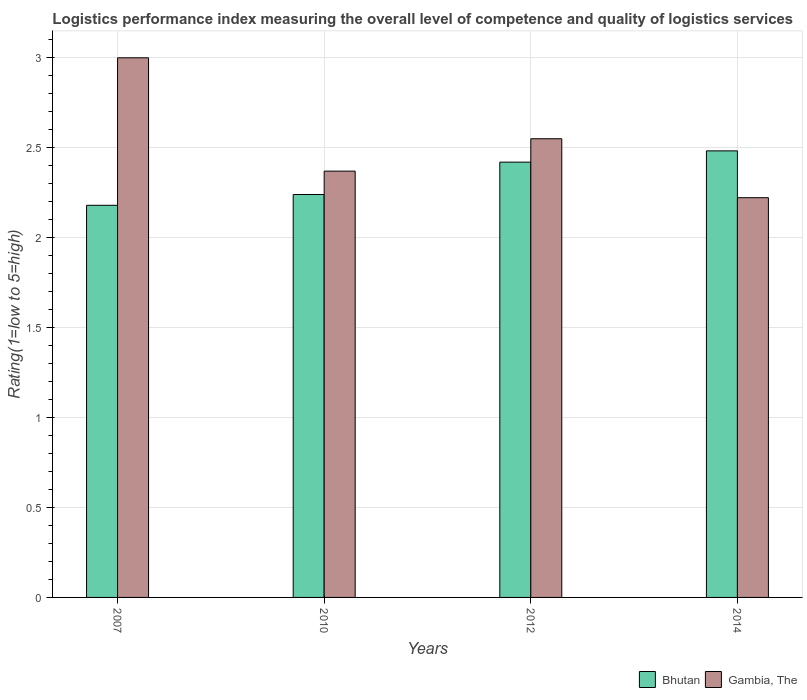How many different coloured bars are there?
Offer a very short reply. 2. How many groups of bars are there?
Make the answer very short. 4. Are the number of bars per tick equal to the number of legend labels?
Your answer should be very brief. Yes. Are the number of bars on each tick of the X-axis equal?
Provide a short and direct response. Yes. In how many cases, is the number of bars for a given year not equal to the number of legend labels?
Offer a very short reply. 0. What is the Logistic performance index in Bhutan in 2007?
Your response must be concise. 2.18. Across all years, what is the maximum Logistic performance index in Bhutan?
Offer a very short reply. 2.48. Across all years, what is the minimum Logistic performance index in Gambia, The?
Provide a short and direct response. 2.22. What is the total Logistic performance index in Bhutan in the graph?
Your answer should be compact. 9.32. What is the difference between the Logistic performance index in Bhutan in 2012 and that in 2014?
Make the answer very short. -0.06. What is the difference between the Logistic performance index in Gambia, The in 2007 and the Logistic performance index in Bhutan in 2014?
Give a very brief answer. 0.52. What is the average Logistic performance index in Gambia, The per year?
Ensure brevity in your answer.  2.54. In the year 2012, what is the difference between the Logistic performance index in Bhutan and Logistic performance index in Gambia, The?
Ensure brevity in your answer.  -0.13. What is the ratio of the Logistic performance index in Bhutan in 2010 to that in 2014?
Keep it short and to the point. 0.9. What is the difference between the highest and the second highest Logistic performance index in Bhutan?
Your answer should be very brief. 0.06. What is the difference between the highest and the lowest Logistic performance index in Gambia, The?
Offer a very short reply. 0.78. Is the sum of the Logistic performance index in Bhutan in 2010 and 2014 greater than the maximum Logistic performance index in Gambia, The across all years?
Ensure brevity in your answer.  Yes. What does the 2nd bar from the left in 2012 represents?
Keep it short and to the point. Gambia, The. What does the 2nd bar from the right in 2012 represents?
Make the answer very short. Bhutan. How many bars are there?
Your response must be concise. 8. Are all the bars in the graph horizontal?
Keep it short and to the point. No. What is the difference between two consecutive major ticks on the Y-axis?
Provide a succinct answer. 0.5. Does the graph contain grids?
Offer a terse response. Yes. How many legend labels are there?
Your answer should be very brief. 2. How are the legend labels stacked?
Your response must be concise. Horizontal. What is the title of the graph?
Your response must be concise. Logistics performance index measuring the overall level of competence and quality of logistics services. Does "Nepal" appear as one of the legend labels in the graph?
Keep it short and to the point. No. What is the label or title of the Y-axis?
Your answer should be compact. Rating(1=low to 5=high). What is the Rating(1=low to 5=high) in Bhutan in 2007?
Provide a succinct answer. 2.18. What is the Rating(1=low to 5=high) in Bhutan in 2010?
Keep it short and to the point. 2.24. What is the Rating(1=low to 5=high) in Gambia, The in 2010?
Ensure brevity in your answer.  2.37. What is the Rating(1=low to 5=high) in Bhutan in 2012?
Ensure brevity in your answer.  2.42. What is the Rating(1=low to 5=high) in Gambia, The in 2012?
Give a very brief answer. 2.55. What is the Rating(1=low to 5=high) in Bhutan in 2014?
Offer a terse response. 2.48. What is the Rating(1=low to 5=high) of Gambia, The in 2014?
Keep it short and to the point. 2.22. Across all years, what is the maximum Rating(1=low to 5=high) of Bhutan?
Your answer should be compact. 2.48. Across all years, what is the maximum Rating(1=low to 5=high) in Gambia, The?
Provide a succinct answer. 3. Across all years, what is the minimum Rating(1=low to 5=high) in Bhutan?
Offer a very short reply. 2.18. Across all years, what is the minimum Rating(1=low to 5=high) in Gambia, The?
Your response must be concise. 2.22. What is the total Rating(1=low to 5=high) of Bhutan in the graph?
Keep it short and to the point. 9.32. What is the total Rating(1=low to 5=high) of Gambia, The in the graph?
Offer a very short reply. 10.14. What is the difference between the Rating(1=low to 5=high) in Bhutan in 2007 and that in 2010?
Give a very brief answer. -0.06. What is the difference between the Rating(1=low to 5=high) in Gambia, The in 2007 and that in 2010?
Ensure brevity in your answer.  0.63. What is the difference between the Rating(1=low to 5=high) in Bhutan in 2007 and that in 2012?
Your answer should be very brief. -0.24. What is the difference between the Rating(1=low to 5=high) of Gambia, The in 2007 and that in 2012?
Your response must be concise. 0.45. What is the difference between the Rating(1=low to 5=high) in Bhutan in 2007 and that in 2014?
Your response must be concise. -0.3. What is the difference between the Rating(1=low to 5=high) in Bhutan in 2010 and that in 2012?
Provide a short and direct response. -0.18. What is the difference between the Rating(1=low to 5=high) in Gambia, The in 2010 and that in 2012?
Give a very brief answer. -0.18. What is the difference between the Rating(1=low to 5=high) in Bhutan in 2010 and that in 2014?
Ensure brevity in your answer.  -0.24. What is the difference between the Rating(1=low to 5=high) in Gambia, The in 2010 and that in 2014?
Provide a short and direct response. 0.15. What is the difference between the Rating(1=low to 5=high) of Bhutan in 2012 and that in 2014?
Keep it short and to the point. -0.06. What is the difference between the Rating(1=low to 5=high) of Gambia, The in 2012 and that in 2014?
Provide a succinct answer. 0.33. What is the difference between the Rating(1=low to 5=high) of Bhutan in 2007 and the Rating(1=low to 5=high) of Gambia, The in 2010?
Your answer should be very brief. -0.19. What is the difference between the Rating(1=low to 5=high) in Bhutan in 2007 and the Rating(1=low to 5=high) in Gambia, The in 2012?
Your response must be concise. -0.37. What is the difference between the Rating(1=low to 5=high) in Bhutan in 2007 and the Rating(1=low to 5=high) in Gambia, The in 2014?
Give a very brief answer. -0.04. What is the difference between the Rating(1=low to 5=high) of Bhutan in 2010 and the Rating(1=low to 5=high) of Gambia, The in 2012?
Make the answer very short. -0.31. What is the difference between the Rating(1=low to 5=high) of Bhutan in 2010 and the Rating(1=low to 5=high) of Gambia, The in 2014?
Your answer should be compact. 0.02. What is the difference between the Rating(1=low to 5=high) of Bhutan in 2012 and the Rating(1=low to 5=high) of Gambia, The in 2014?
Make the answer very short. 0.2. What is the average Rating(1=low to 5=high) of Bhutan per year?
Give a very brief answer. 2.33. What is the average Rating(1=low to 5=high) in Gambia, The per year?
Your answer should be very brief. 2.54. In the year 2007, what is the difference between the Rating(1=low to 5=high) in Bhutan and Rating(1=low to 5=high) in Gambia, The?
Offer a terse response. -0.82. In the year 2010, what is the difference between the Rating(1=low to 5=high) of Bhutan and Rating(1=low to 5=high) of Gambia, The?
Keep it short and to the point. -0.13. In the year 2012, what is the difference between the Rating(1=low to 5=high) in Bhutan and Rating(1=low to 5=high) in Gambia, The?
Give a very brief answer. -0.13. In the year 2014, what is the difference between the Rating(1=low to 5=high) in Bhutan and Rating(1=low to 5=high) in Gambia, The?
Your answer should be very brief. 0.26. What is the ratio of the Rating(1=low to 5=high) of Bhutan in 2007 to that in 2010?
Offer a terse response. 0.97. What is the ratio of the Rating(1=low to 5=high) of Gambia, The in 2007 to that in 2010?
Make the answer very short. 1.27. What is the ratio of the Rating(1=low to 5=high) of Bhutan in 2007 to that in 2012?
Offer a terse response. 0.9. What is the ratio of the Rating(1=low to 5=high) in Gambia, The in 2007 to that in 2012?
Give a very brief answer. 1.18. What is the ratio of the Rating(1=low to 5=high) of Bhutan in 2007 to that in 2014?
Offer a very short reply. 0.88. What is the ratio of the Rating(1=low to 5=high) of Gambia, The in 2007 to that in 2014?
Your answer should be very brief. 1.35. What is the ratio of the Rating(1=low to 5=high) of Bhutan in 2010 to that in 2012?
Offer a terse response. 0.93. What is the ratio of the Rating(1=low to 5=high) of Gambia, The in 2010 to that in 2012?
Your answer should be compact. 0.93. What is the ratio of the Rating(1=low to 5=high) in Bhutan in 2010 to that in 2014?
Keep it short and to the point. 0.9. What is the ratio of the Rating(1=low to 5=high) in Gambia, The in 2010 to that in 2014?
Your response must be concise. 1.07. What is the ratio of the Rating(1=low to 5=high) in Bhutan in 2012 to that in 2014?
Offer a very short reply. 0.97. What is the ratio of the Rating(1=low to 5=high) of Gambia, The in 2012 to that in 2014?
Make the answer very short. 1.15. What is the difference between the highest and the second highest Rating(1=low to 5=high) of Bhutan?
Give a very brief answer. 0.06. What is the difference between the highest and the second highest Rating(1=low to 5=high) in Gambia, The?
Keep it short and to the point. 0.45. What is the difference between the highest and the lowest Rating(1=low to 5=high) in Bhutan?
Offer a very short reply. 0.3. What is the difference between the highest and the lowest Rating(1=low to 5=high) of Gambia, The?
Make the answer very short. 0.78. 